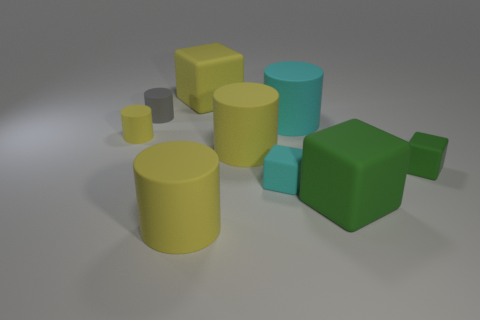Subtract all yellow cylinders. How many were subtracted if there are1yellow cylinders left? 2 Subtract all yellow blocks. How many yellow cylinders are left? 3 Subtract 1 cubes. How many cubes are left? 3 Subtract all big cyan rubber cylinders. How many cylinders are left? 4 Subtract all cyan cylinders. How many cylinders are left? 4 Subtract all blue cylinders. Subtract all gray spheres. How many cylinders are left? 5 Add 1 small gray cylinders. How many objects exist? 10 Subtract all blocks. How many objects are left? 5 Subtract all gray cylinders. Subtract all green cubes. How many objects are left? 6 Add 2 big cyan objects. How many big cyan objects are left? 3 